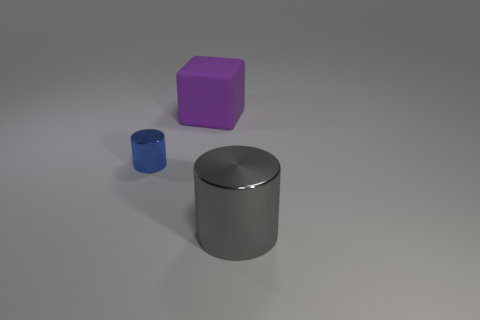Add 2 large gray objects. How many objects exist? 5 Subtract all blocks. How many objects are left? 2 Subtract all yellow cylinders. Subtract all gray blocks. How many cylinders are left? 2 Subtract all gray blocks. How many blue cylinders are left? 1 Subtract all gray cylinders. Subtract all large gray cylinders. How many objects are left? 1 Add 2 big cubes. How many big cubes are left? 3 Add 1 small green cylinders. How many small green cylinders exist? 1 Subtract 1 blue cylinders. How many objects are left? 2 Subtract 1 cubes. How many cubes are left? 0 